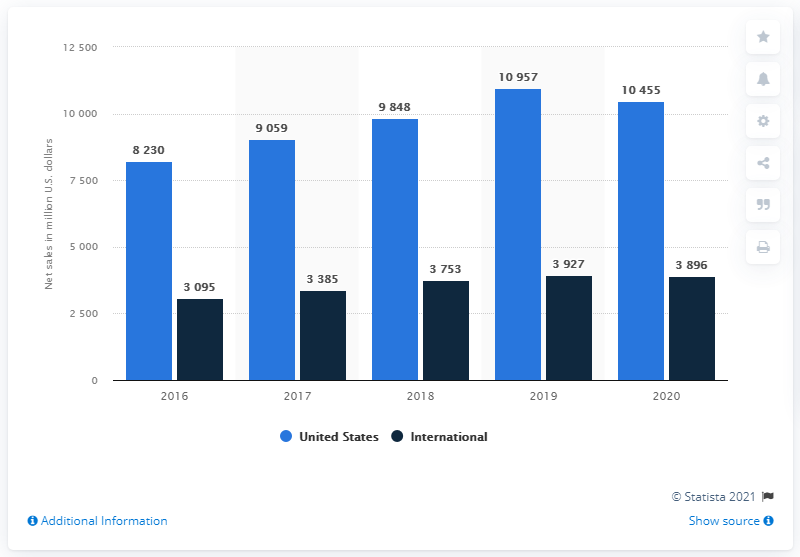Mention a couple of crucial points in this snapshot. In 2019, the difference in net sales between the United States and international regions was the largest. In 2014, Stryker's sales in the United States were 8,230. The dark blue bars represent the international aspect of the data being shown. 